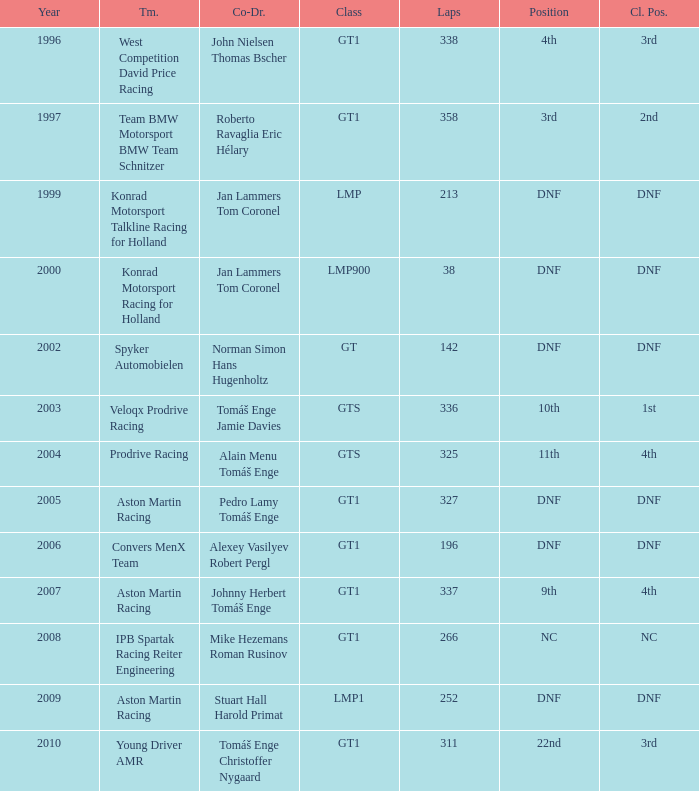Which position finished 3rd in class and completed less than 338 laps? 22nd. 